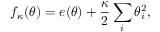<formula> <loc_0><loc_0><loc_500><loc_500>f _ { \kappa } ( { \theta } ) = e ( { \theta } ) + \frac { \kappa } { 2 } \sum _ { i } \theta _ { i } ^ { 2 } ,</formula> 